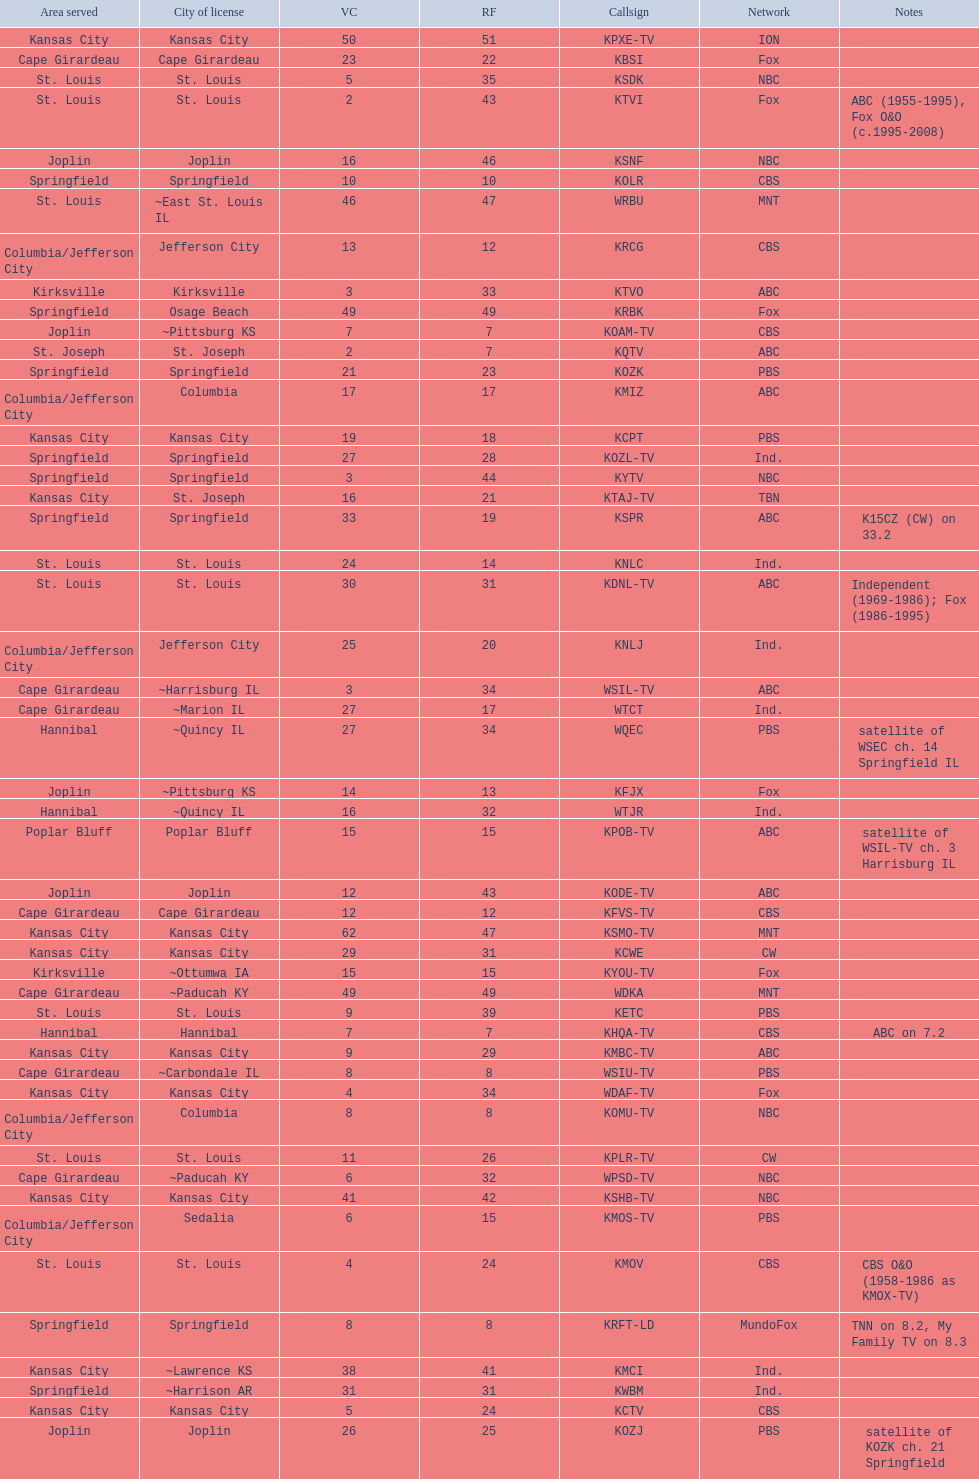Kode-tv and wsil-tv both are a part of which network? ABC. 